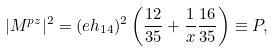Convert formula to latex. <formula><loc_0><loc_0><loc_500><loc_500>| M ^ { p z } | ^ { 2 } = ( e h _ { 1 4 } ) ^ { 2 } \left ( \frac { 1 2 } { 3 5 } + \frac { 1 } { x } \frac { 1 6 } { 3 5 } \right ) \equiv P ,</formula> 